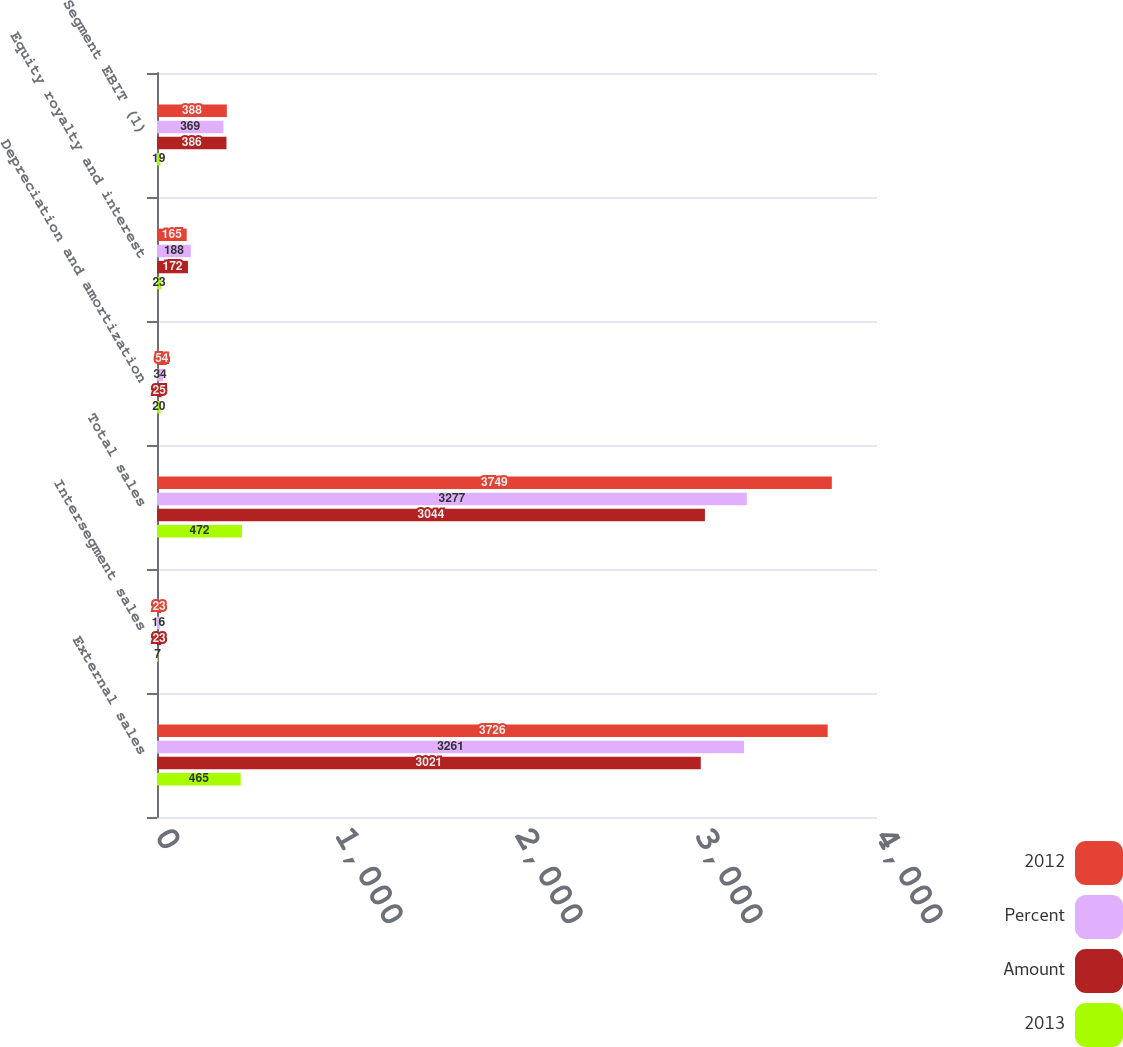Convert chart. <chart><loc_0><loc_0><loc_500><loc_500><stacked_bar_chart><ecel><fcel>External sales<fcel>Intersegment sales<fcel>Total sales<fcel>Depreciation and amortization<fcel>Equity royalty and interest<fcel>Segment EBIT (1)<nl><fcel>2012<fcel>3726<fcel>23<fcel>3749<fcel>54<fcel>165<fcel>388<nl><fcel>Percent<fcel>3261<fcel>16<fcel>3277<fcel>34<fcel>188<fcel>369<nl><fcel>Amount<fcel>3021<fcel>23<fcel>3044<fcel>25<fcel>172<fcel>386<nl><fcel>2013<fcel>465<fcel>7<fcel>472<fcel>20<fcel>23<fcel>19<nl></chart> 